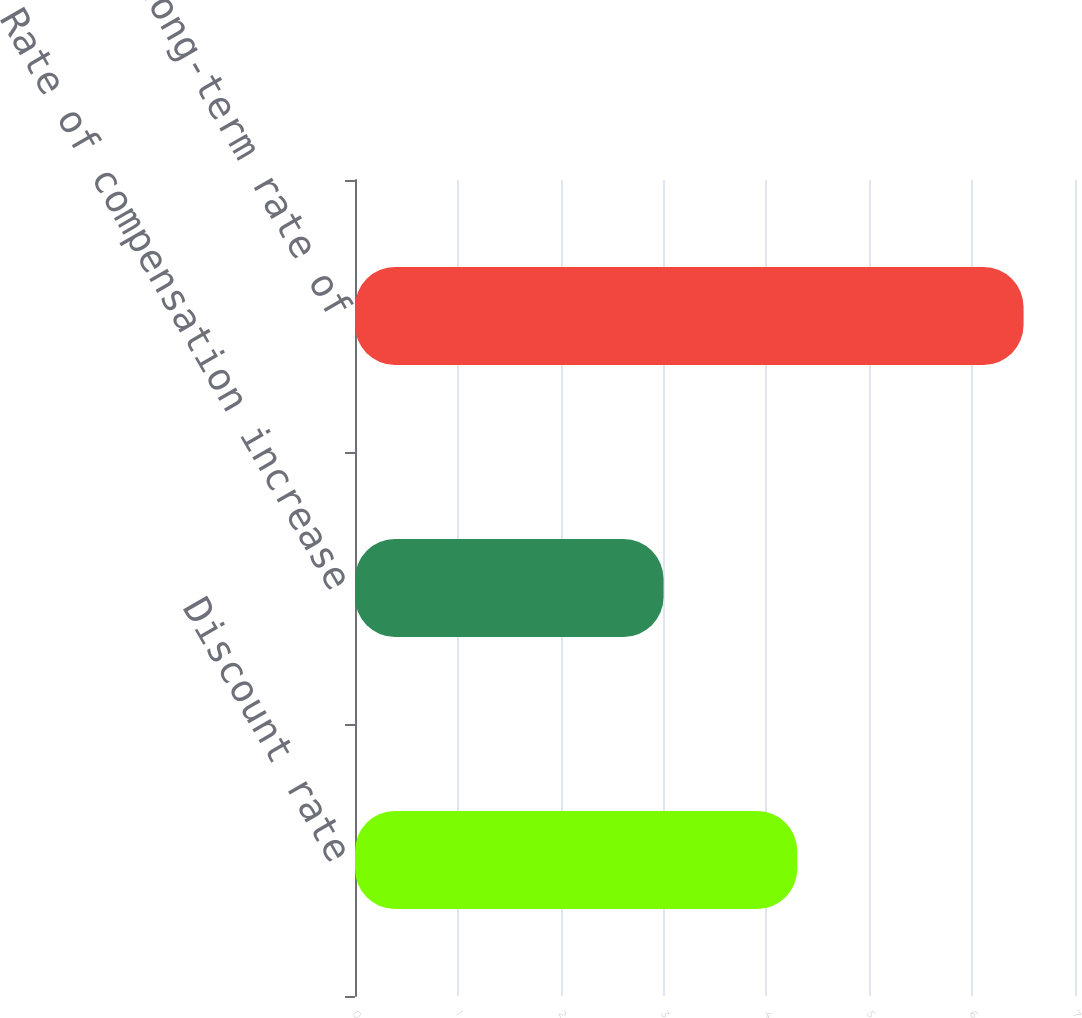Convert chart. <chart><loc_0><loc_0><loc_500><loc_500><bar_chart><fcel>Discount rate<fcel>Rate of compensation increase<fcel>Expected long-term rate of<nl><fcel>4.3<fcel>3<fcel>6.5<nl></chart> 